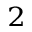Convert formula to latex. <formula><loc_0><loc_0><loc_500><loc_500>^ { 2 }</formula> 